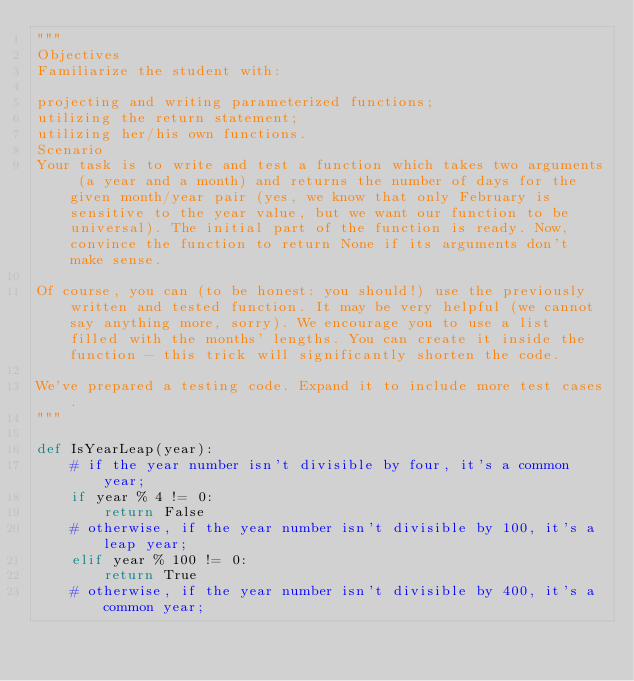<code> <loc_0><loc_0><loc_500><loc_500><_Python_>"""
Objectives
Familiarize the student with:

projecting and writing parameterized functions;
utilizing the return statement;
utilizing her/his own functions.
Scenario
Your task is to write and test a function which takes two arguments (a year and a month) and returns the number of days for the given month/year pair (yes, we know that only February is sensitive to the year value, but we want our function to be universal). The initial part of the function is ready. Now, convince the function to return None if its arguments don't make sense.

Of course, you can (to be honest: you should!) use the previously written and tested function. It may be very helpful (we cannot say anything more, sorry). We encourage you to use a list filled with the months' lengths. You can create it inside the function - this trick will significantly shorten the code.

We've prepared a testing code. Expand it to include more test cases.
"""

def IsYearLeap(year):
    # if the year number isn't divisible by four, it's a common year;
    if year % 4 != 0:
        return False
    # otherwise, if the year number isn't divisible by 100, it's a leap year;
    elif year % 100 != 0:
        return True
    # otherwise, if the year number isn't divisible by 400, it's a common year;</code> 